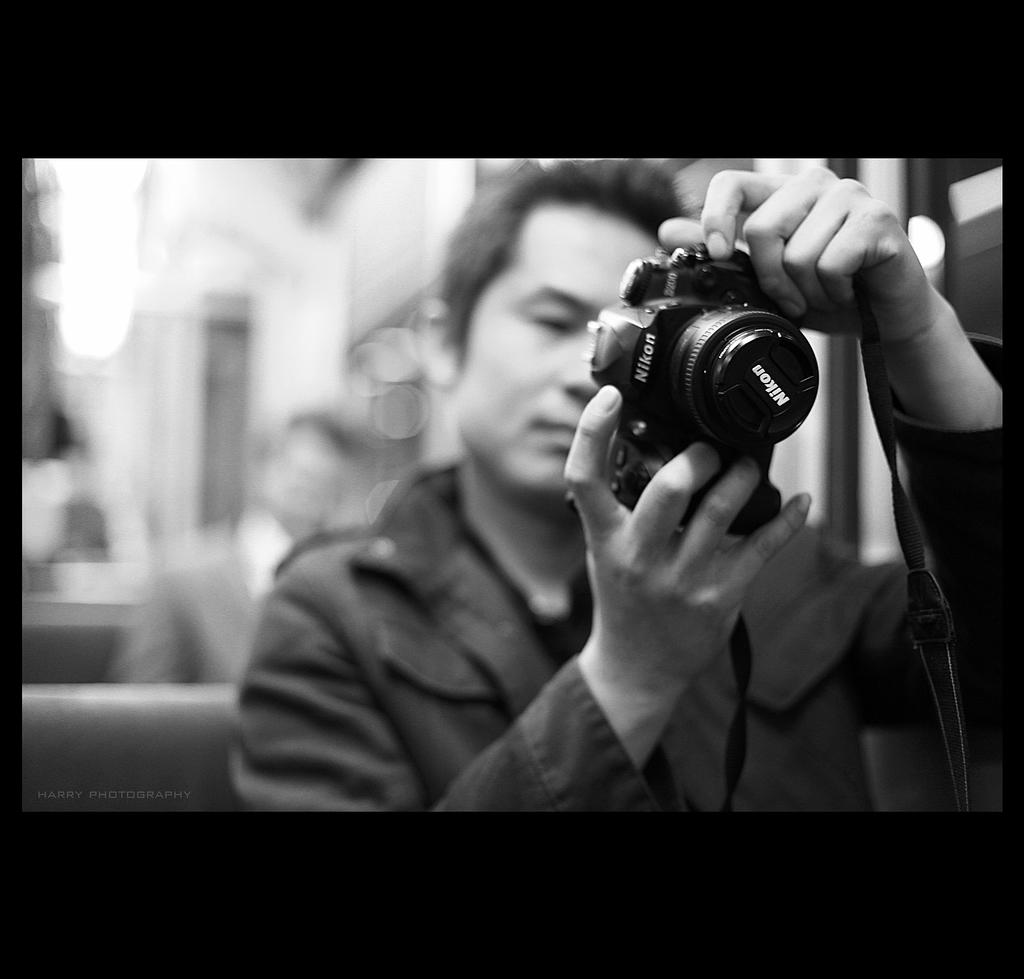What is the main subject of the image? There is a man in the image. What is the man holding in the image? The man is holding a camera. What type of leaf can be seen falling from the camera in the image? There is no leaf present in the image, and the camera is not depicted as having any leaves. 